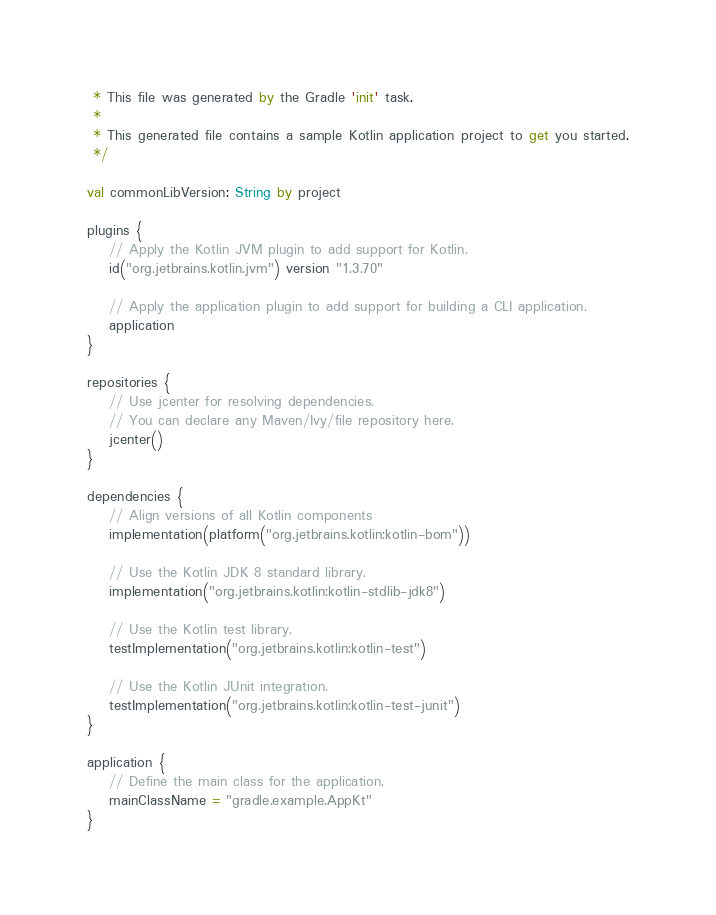<code> <loc_0><loc_0><loc_500><loc_500><_Kotlin_> * This file was generated by the Gradle 'init' task.
 *
 * This generated file contains a sample Kotlin application project to get you started.
 */

val commonLibVersion: String by project

plugins {
    // Apply the Kotlin JVM plugin to add support for Kotlin.
    id("org.jetbrains.kotlin.jvm") version "1.3.70"

    // Apply the application plugin to add support for building a CLI application.
    application
}

repositories {
    // Use jcenter for resolving dependencies.
    // You can declare any Maven/Ivy/file repository here.
    jcenter()
}

dependencies {
    // Align versions of all Kotlin components
    implementation(platform("org.jetbrains.kotlin:kotlin-bom"))

    // Use the Kotlin JDK 8 standard library.
    implementation("org.jetbrains.kotlin:kotlin-stdlib-jdk8")

    // Use the Kotlin test library.
    testImplementation("org.jetbrains.kotlin:kotlin-test")

    // Use the Kotlin JUnit integration.
    testImplementation("org.jetbrains.kotlin:kotlin-test-junit")
}

application {
    // Define the main class for the application.
    mainClassName = "gradle.example.AppKt"
}
</code> 